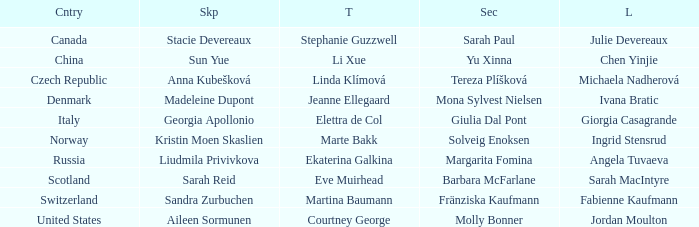What skip has switzerland as the country? Sandra Zurbuchen. 